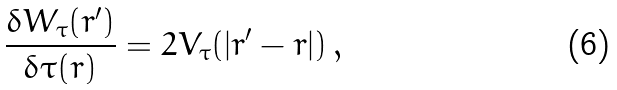Convert formula to latex. <formula><loc_0><loc_0><loc_500><loc_500>\frac { \delta W _ { \tau } ( r ^ { \prime } ) } { \delta \tau ( r ) } = 2 V _ { \tau } ( | r ^ { \prime } - r | ) \, ,</formula> 